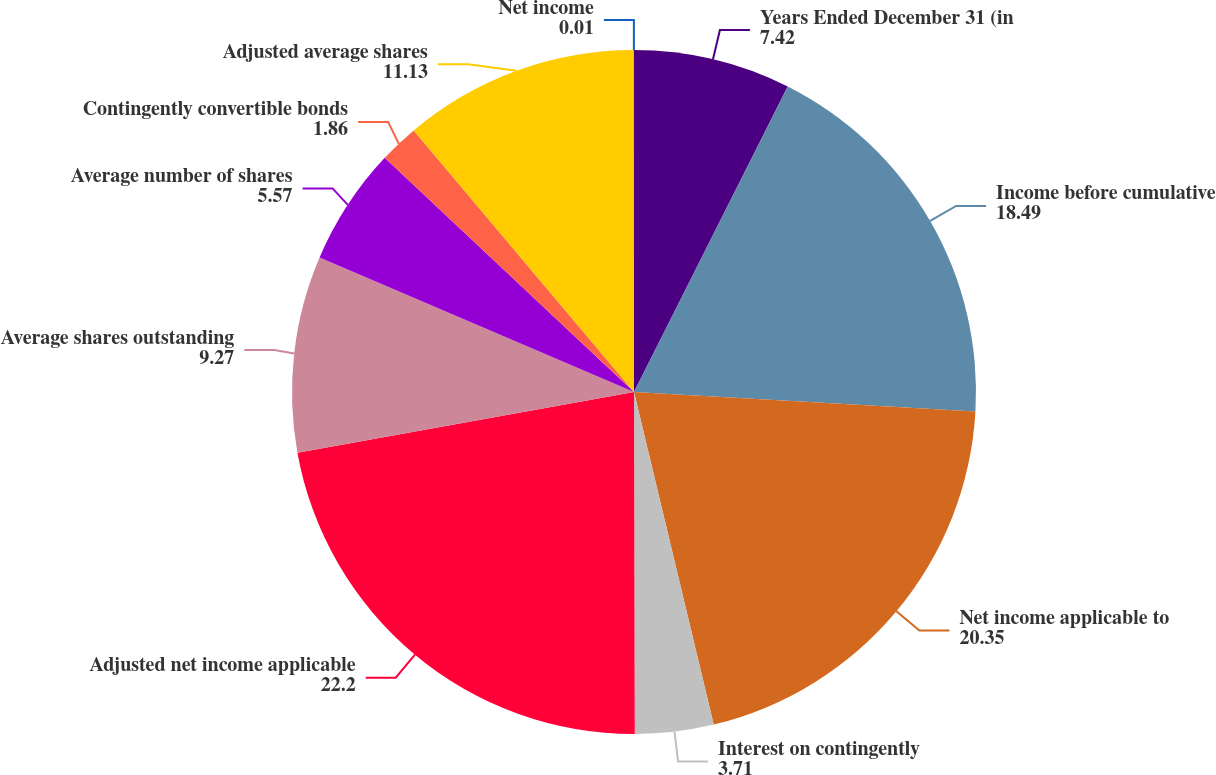Convert chart. <chart><loc_0><loc_0><loc_500><loc_500><pie_chart><fcel>Years Ended December 31 (in<fcel>Income before cumulative<fcel>Net income applicable to<fcel>Interest on contingently<fcel>Adjusted net income applicable<fcel>Average shares outstanding<fcel>Average number of shares<fcel>Contingently convertible bonds<fcel>Adjusted average shares<fcel>Net income<nl><fcel>7.42%<fcel>18.49%<fcel>20.35%<fcel>3.71%<fcel>22.2%<fcel>9.27%<fcel>5.57%<fcel>1.86%<fcel>11.13%<fcel>0.01%<nl></chart> 